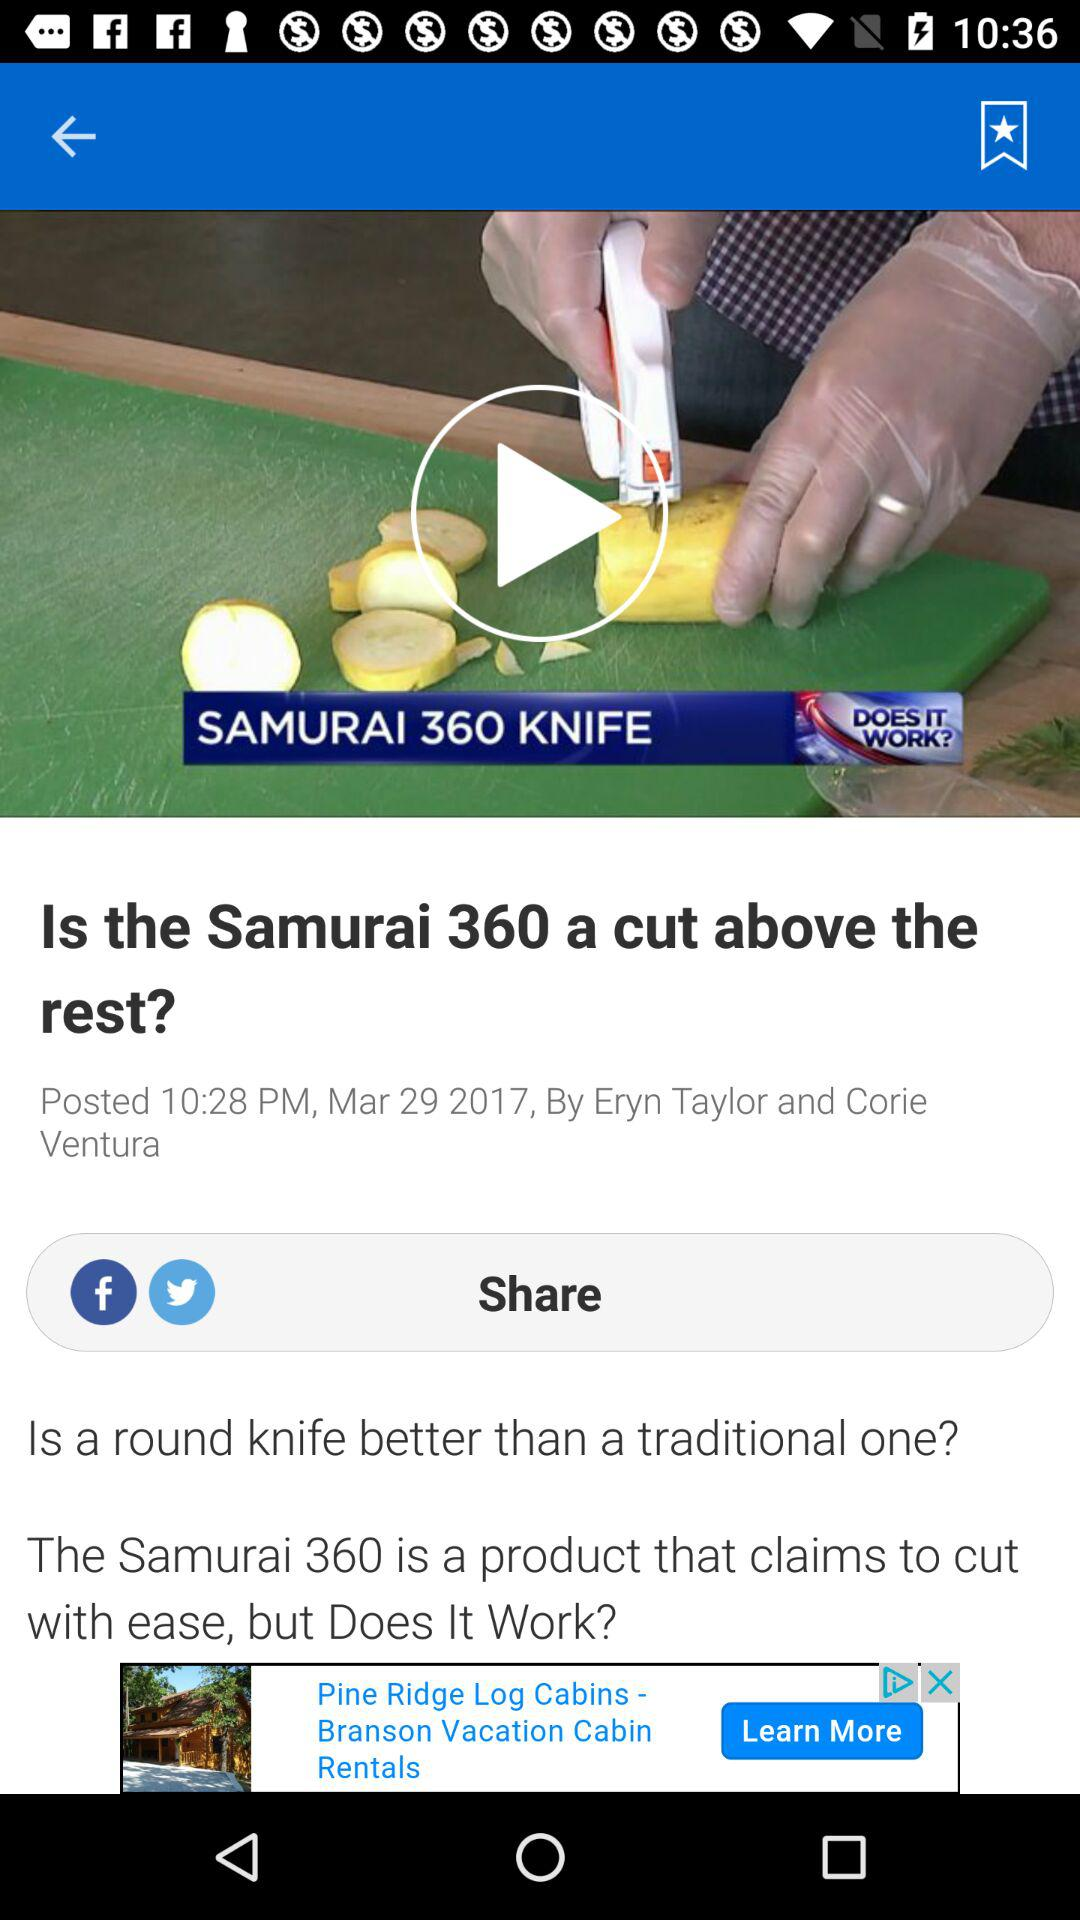What is the posted time of the article? The posted time of the article is 10:28 PM. 